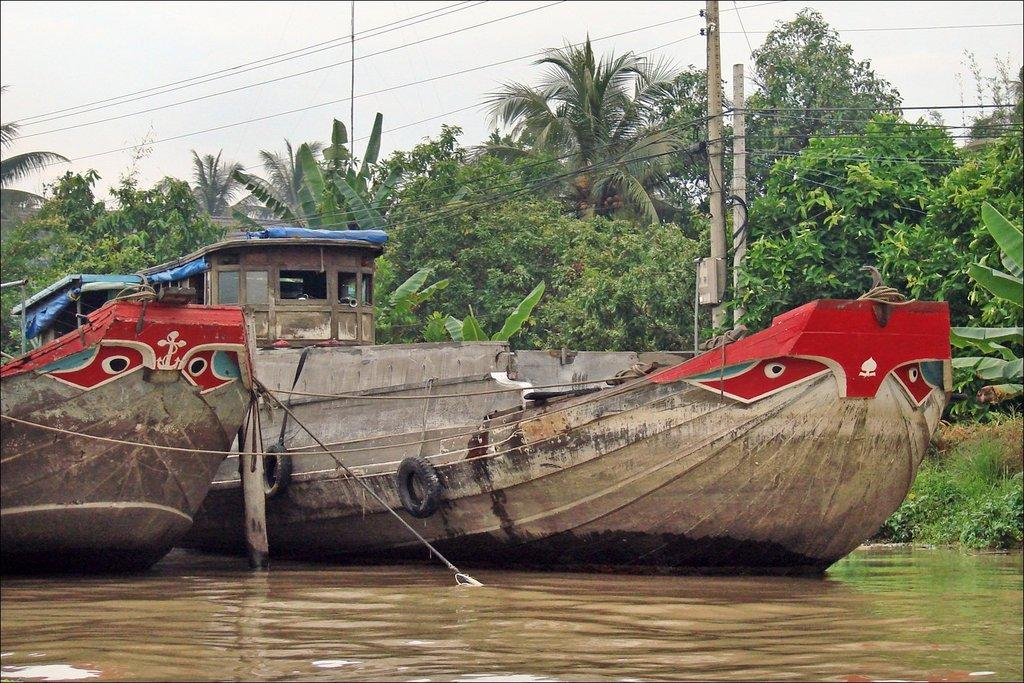How many boat houses are in the image? There are two boat houses in the image. Where are the boat houses located? The boat houses are on the water surface. What can be seen behind the boat houses? There are trees visible behind the boats. What is present in front of the trees? There are two current poles with many wires in front of the trees. What type of wine is being served in the boat houses? There is no indication of wine or any beverage being served in the boat houses in the image. 